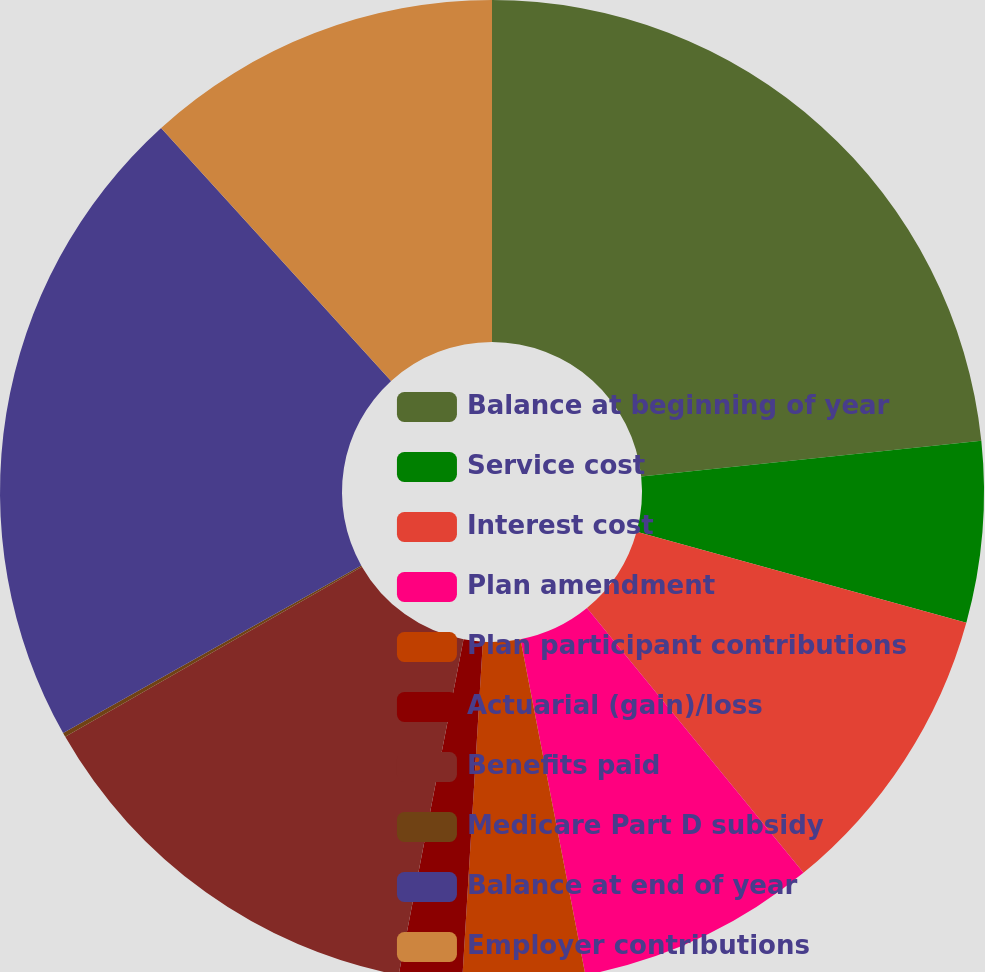Convert chart to OTSL. <chart><loc_0><loc_0><loc_500><loc_500><pie_chart><fcel>Balance at beginning of year<fcel>Service cost<fcel>Interest cost<fcel>Plan amendment<fcel>Plan participant contributions<fcel>Actuarial (gain)/loss<fcel>Benefits paid<fcel>Medicare Part D subsidy<fcel>Balance at end of year<fcel>Employer contributions<nl><fcel>23.34%<fcel>5.94%<fcel>9.81%<fcel>7.87%<fcel>4.01%<fcel>2.07%<fcel>13.67%<fcel>0.14%<fcel>21.41%<fcel>11.74%<nl></chart> 